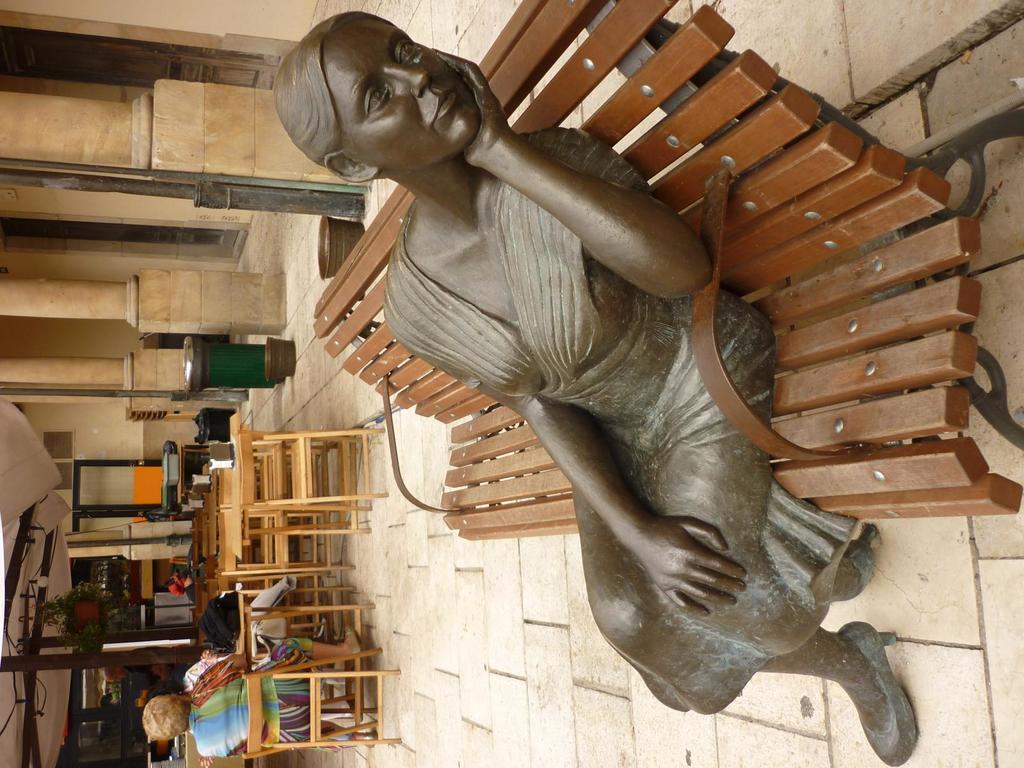Could you give a brief overview of what you see in this image? In the picture we can see a path with a bench on it we can see a sculpture of a woman sitting and some far away from it we can see some chairs and a person sitting on it and in the background we can see a wall with a door and besides we can see some poles and a dustbin near it. 